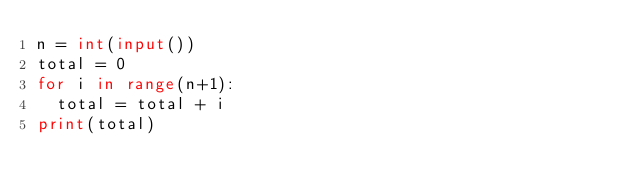Convert code to text. <code><loc_0><loc_0><loc_500><loc_500><_Python_>n = int(input())
total = 0
for i in range(n+1):
  total = total + i
print(total)</code> 